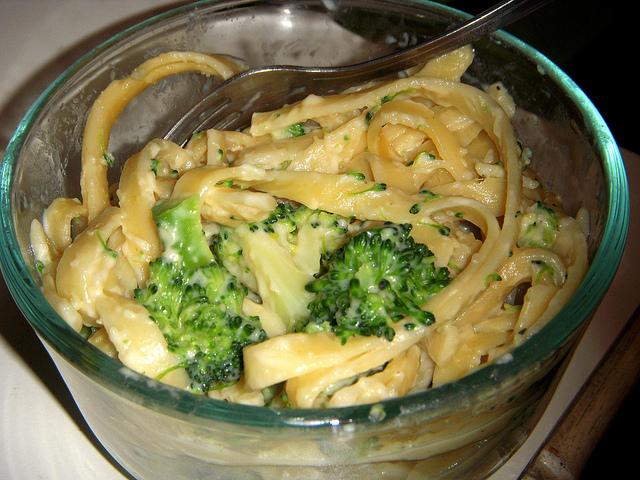What is the dish made of?
Give a very brief answer. Pasta. What vegetable is in the pasta?
Answer briefly. Broccoli. Is there pasta in this dish?
Write a very short answer. Yes. 